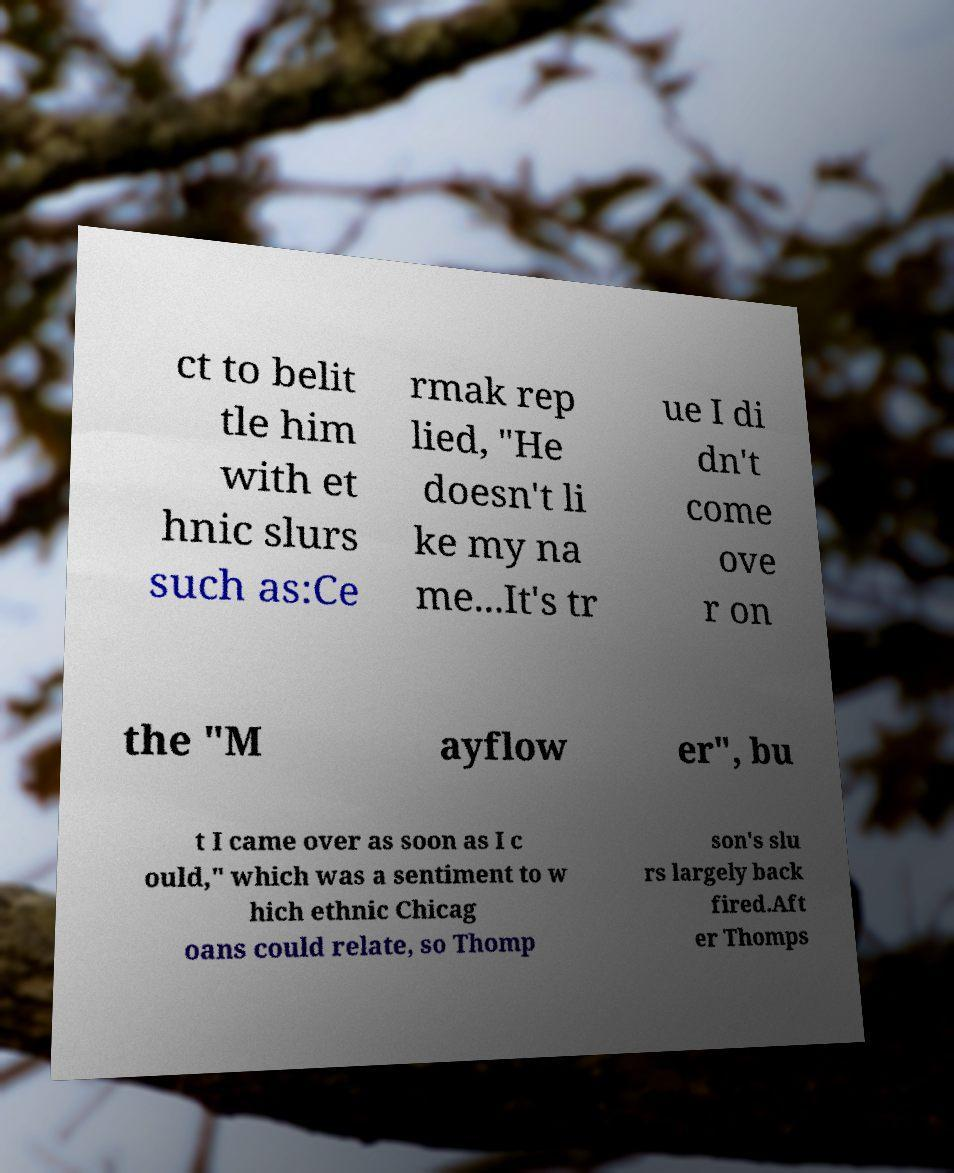Could you assist in decoding the text presented in this image and type it out clearly? ct to belit tle him with et hnic slurs such as:Ce rmak rep lied, "He doesn't li ke my na me...It's tr ue I di dn't come ove r on the "M ayflow er", bu t I came over as soon as I c ould," which was a sentiment to w hich ethnic Chicag oans could relate, so Thomp son's slu rs largely back fired.Aft er Thomps 